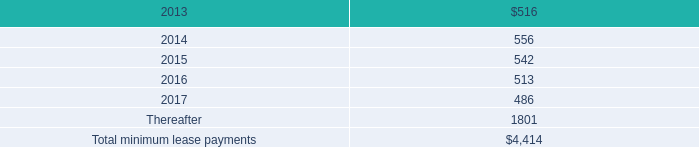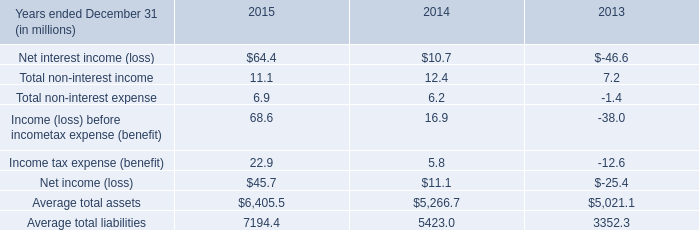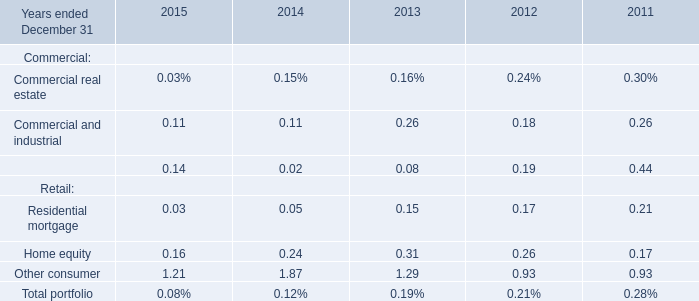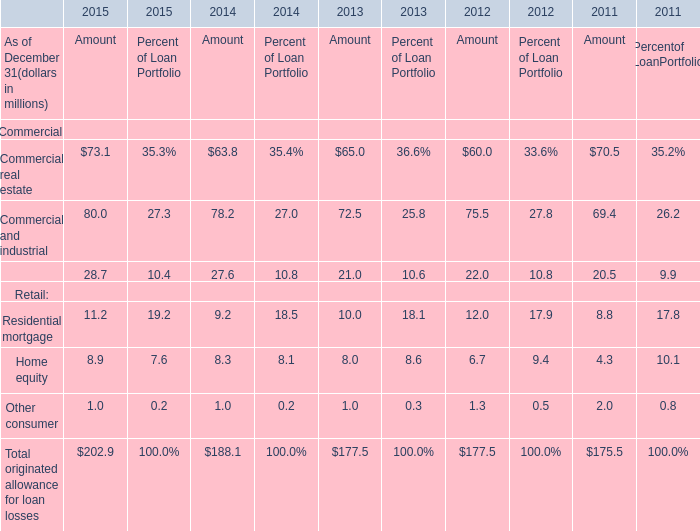what was the increase in rent expense under all operating leases , including both cancelable and noncancelable leases between 2012 and 2011 , in millions? 
Computations: (488 - 338)
Answer: 150.0. 